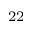Convert formula to latex. <formula><loc_0><loc_0><loc_500><loc_500>^ { 2 2 }</formula> 